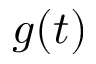<formula> <loc_0><loc_0><loc_500><loc_500>g ( t )</formula> 